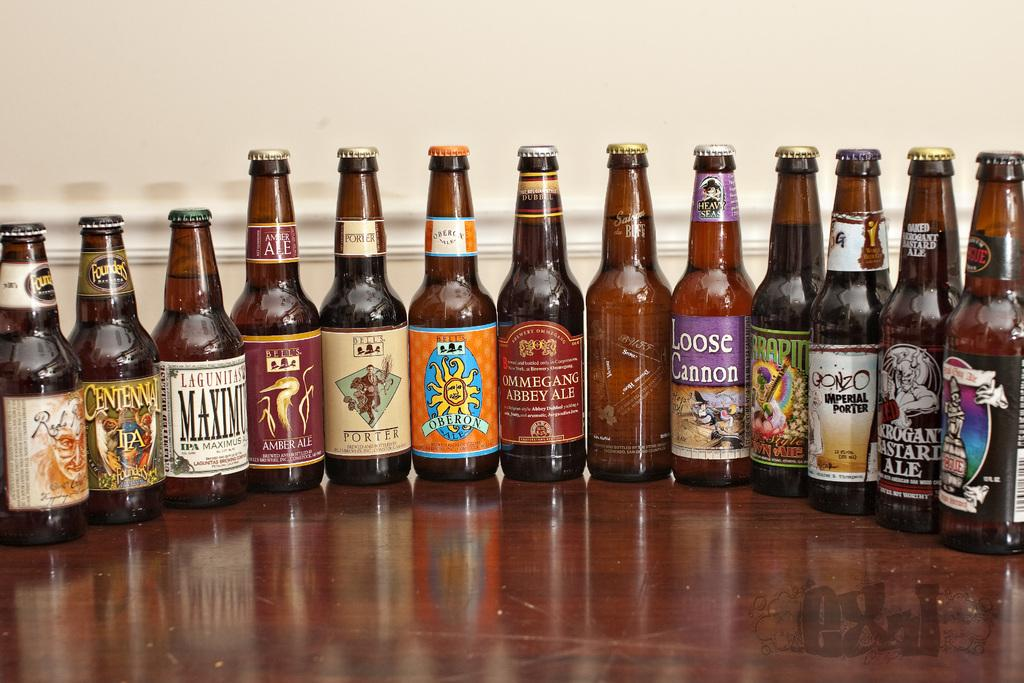<image>
Offer a succinct explanation of the picture presented. Several beer bottles are lined up, including one called Loose Cannon. 